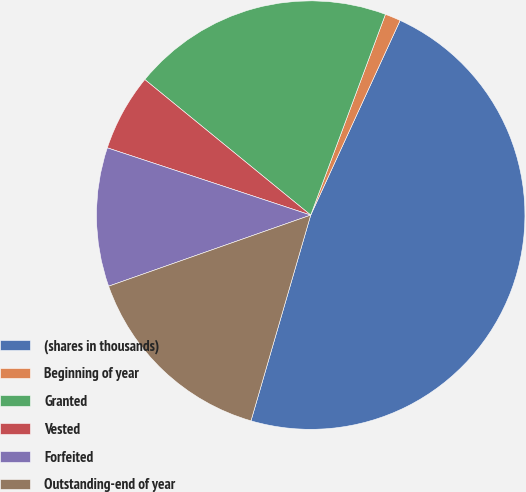<chart> <loc_0><loc_0><loc_500><loc_500><pie_chart><fcel>(shares in thousands)<fcel>Beginning of year<fcel>Granted<fcel>Vested<fcel>Forfeited<fcel>Outstanding-end of year<nl><fcel>47.65%<fcel>1.18%<fcel>19.77%<fcel>5.82%<fcel>10.47%<fcel>15.12%<nl></chart> 